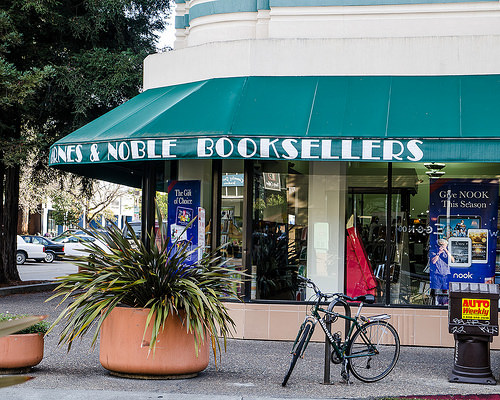<image>
Is the bike next to the bookstore? Yes. The bike is positioned adjacent to the bookstore, located nearby in the same general area. 